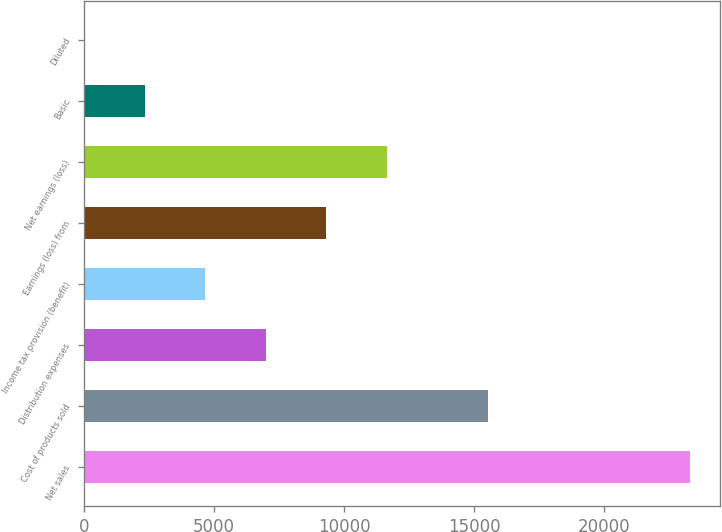<chart> <loc_0><loc_0><loc_500><loc_500><bar_chart><fcel>Net sales<fcel>Cost of products sold<fcel>Distribution expenses<fcel>Income tax provision (benefit)<fcel>Earnings (loss) from<fcel>Net earnings (loss)<fcel>Basic<fcel>Diluted<nl><fcel>23274<fcel>15535<fcel>6985.6<fcel>4658.68<fcel>9312.52<fcel>11639.4<fcel>2331.76<fcel>4.84<nl></chart> 